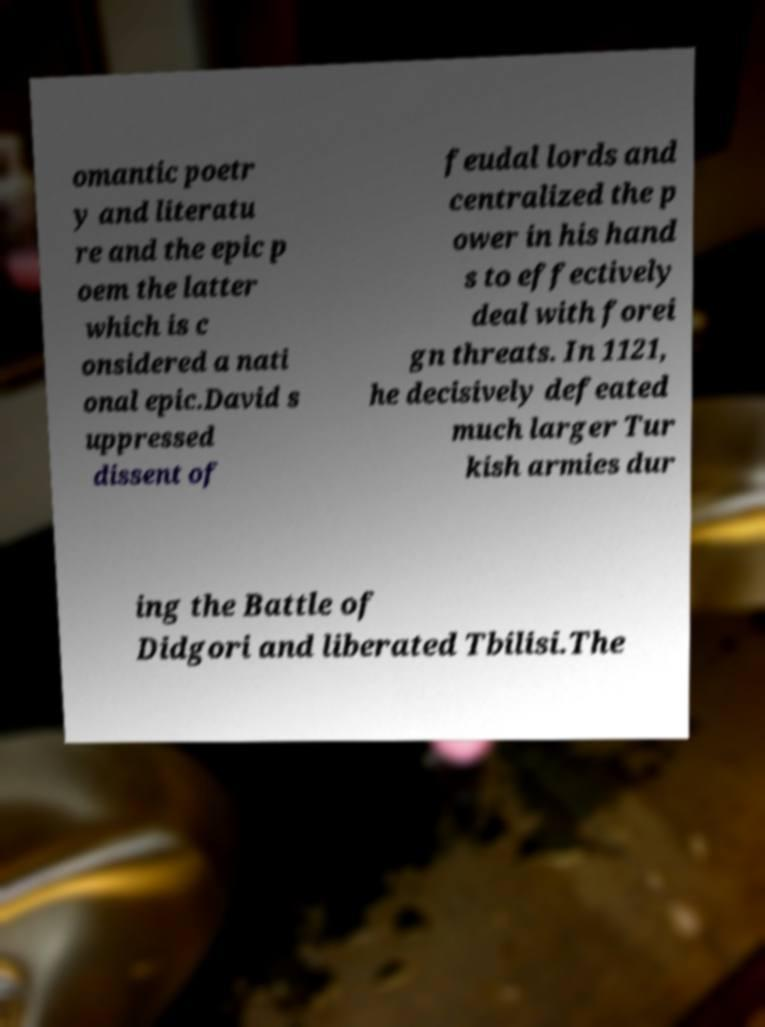Can you read and provide the text displayed in the image?This photo seems to have some interesting text. Can you extract and type it out for me? omantic poetr y and literatu re and the epic p oem the latter which is c onsidered a nati onal epic.David s uppressed dissent of feudal lords and centralized the p ower in his hand s to effectively deal with forei gn threats. In 1121, he decisively defeated much larger Tur kish armies dur ing the Battle of Didgori and liberated Tbilisi.The 